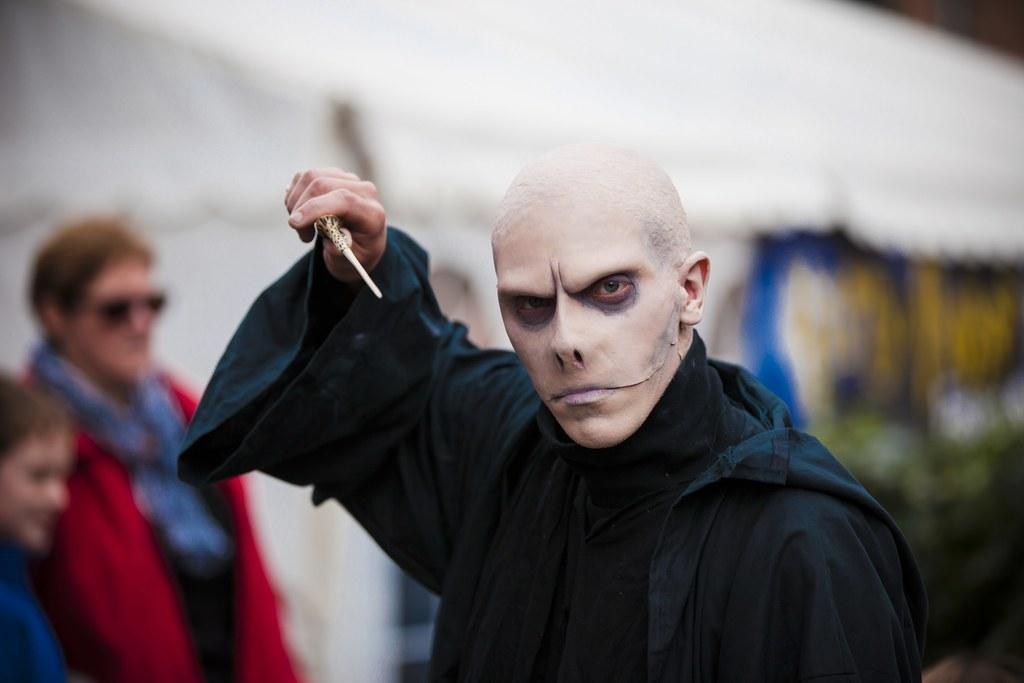What is the main subject of the image? There is a man standing in the middle of the image. What is the man holding in the image? The man is holding a stick. Are there any other people in the image? Yes, there are people standing behind the man. Can you describe the background of the image? The background of the image is blurred. What type of grass is growing in the background of the image? There is no grass visible in the image; the background is blurred. Can you tell me how many basketballs are being used by the people in the image? There are no basketballs present in the image. 